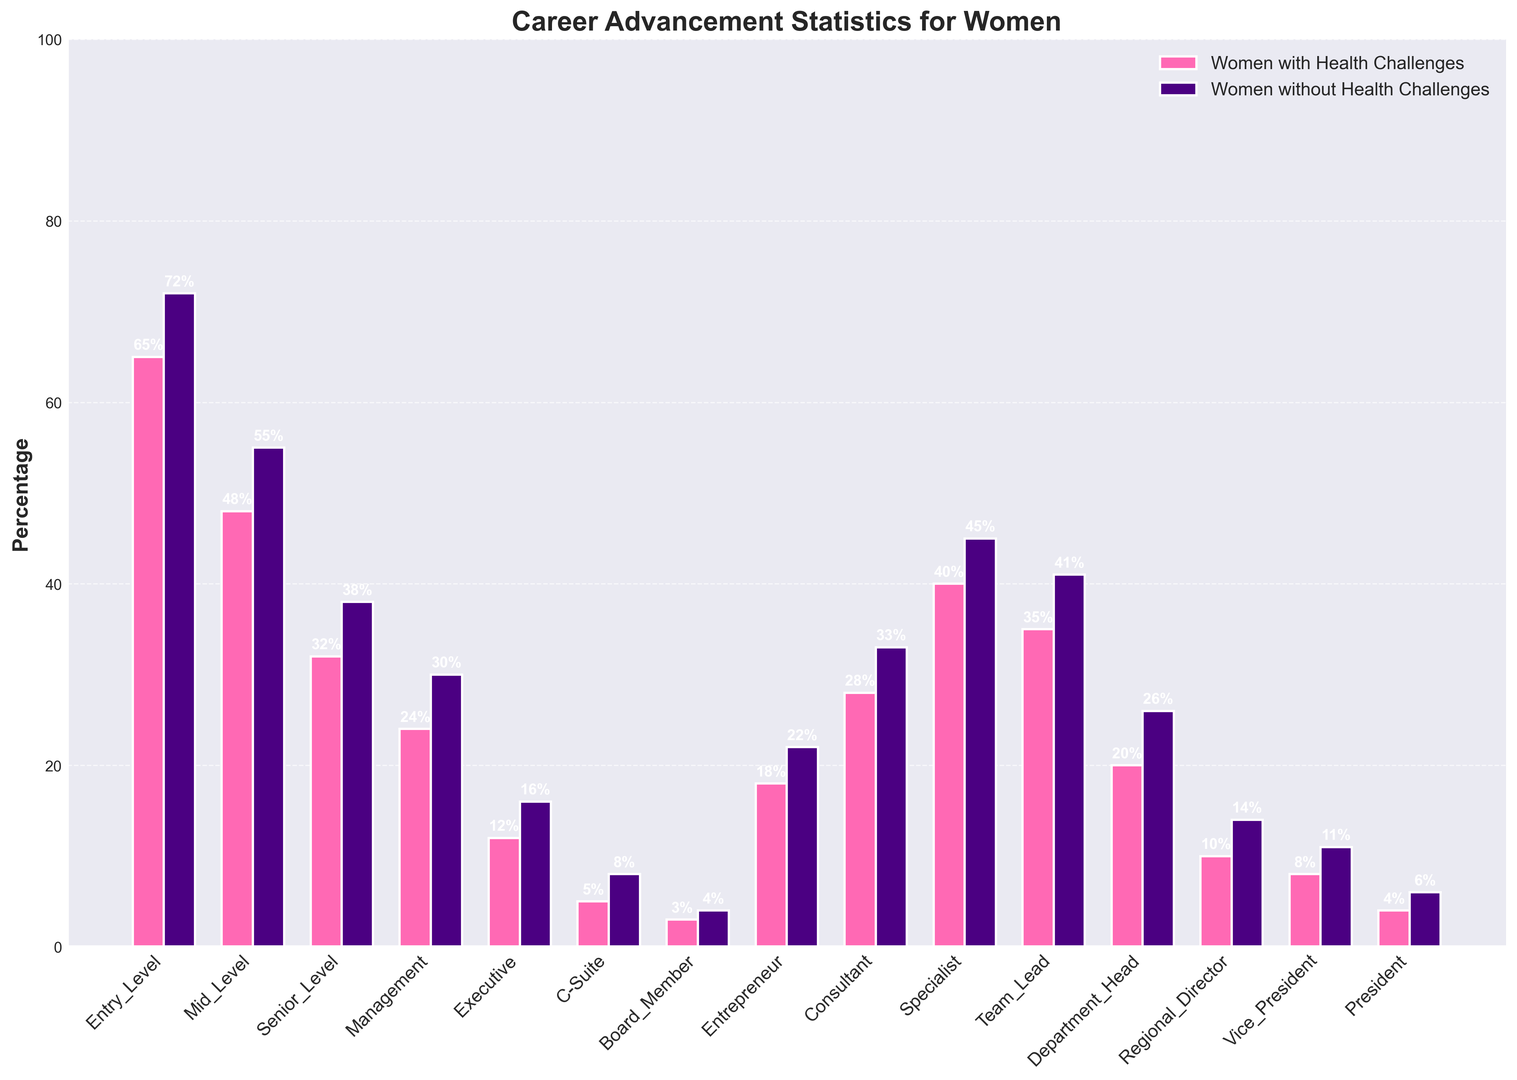What is the difference in percentage between women with health challenges and those without at the mid-level career stage? The percentage for women with health challenges at the mid-level is 48%, and for women without health challenges, it is 55%. The difference in percentage is calculated as 55% - 48% = 7%.
Answer: 7% Which career level shows the smallest gap in percentage between women with health challenges and those without? By examining the differences for each career level, the smallest gap occurs at the Board Member level: 4% - 3% = 1%.
Answer: Board Member How many more women without health challenges are in the entrepreneur category compared to women with health challenges? In the entrepreneur category, there are 22% women without health challenges and 18% women with health challenges. The difference is 22% - 18% = 4%.
Answer: 4% For women with health challenges, which career level has the highest percentage? Looking at all career levels for women with health challenges, the Entry Level has the highest percentage at 65%.
Answer: Entry Level What is the average percentage of women without health challenges in the C-Suite, Vice President, and President levels? The percentages for women without health challenges are 8% (C-Suite), 11% (Vice President), and 6% (President). The average is calculated as (8 + 11 + 6) / 3 = 8.33%.
Answer: 8.33% Do women without health challenges have a higher percentage in the consultant category compared to women with health challenges? Yes, women without health challenges have a higher percentage in the consultant category (33%) compared to women with health challenges (28%).
Answer: Yes Which career level shows the greatest percentage difference in favor of women without health challenges? Calculating the differences for each level, the greatest difference is at the Management level: 30% - 24% = 6%.
Answer: Management Among all career levels, where do women with health challenges have the smallest percentage? Examining all career levels, women with health challenges have the smallest percentage at the Board Member level, which is 3%.
Answer: Board Member Is the percentage of women without health challenges higher in the Specialist category compared to women with health challenges in the Team Lead category? Yes, the percentage of women without health challenges in the Specialist category is 45%, which is higher than the percentage of women with health challenges in the Team Lead category, which is 35%.
Answer: Yes What is the total percentage of women with health challenges in the Executive and C-Suite levels combined? For women with health challenges, the percentage is 12% for the Executive level and 5% for the C-Suite level. The total is 12% + 5% = 17%.
Answer: 17% 